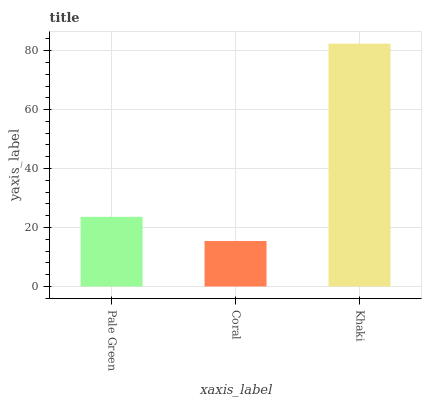Is Khaki the minimum?
Answer yes or no. No. Is Coral the maximum?
Answer yes or no. No. Is Khaki greater than Coral?
Answer yes or no. Yes. Is Coral less than Khaki?
Answer yes or no. Yes. Is Coral greater than Khaki?
Answer yes or no. No. Is Khaki less than Coral?
Answer yes or no. No. Is Pale Green the high median?
Answer yes or no. Yes. Is Pale Green the low median?
Answer yes or no. Yes. Is Khaki the high median?
Answer yes or no. No. Is Coral the low median?
Answer yes or no. No. 